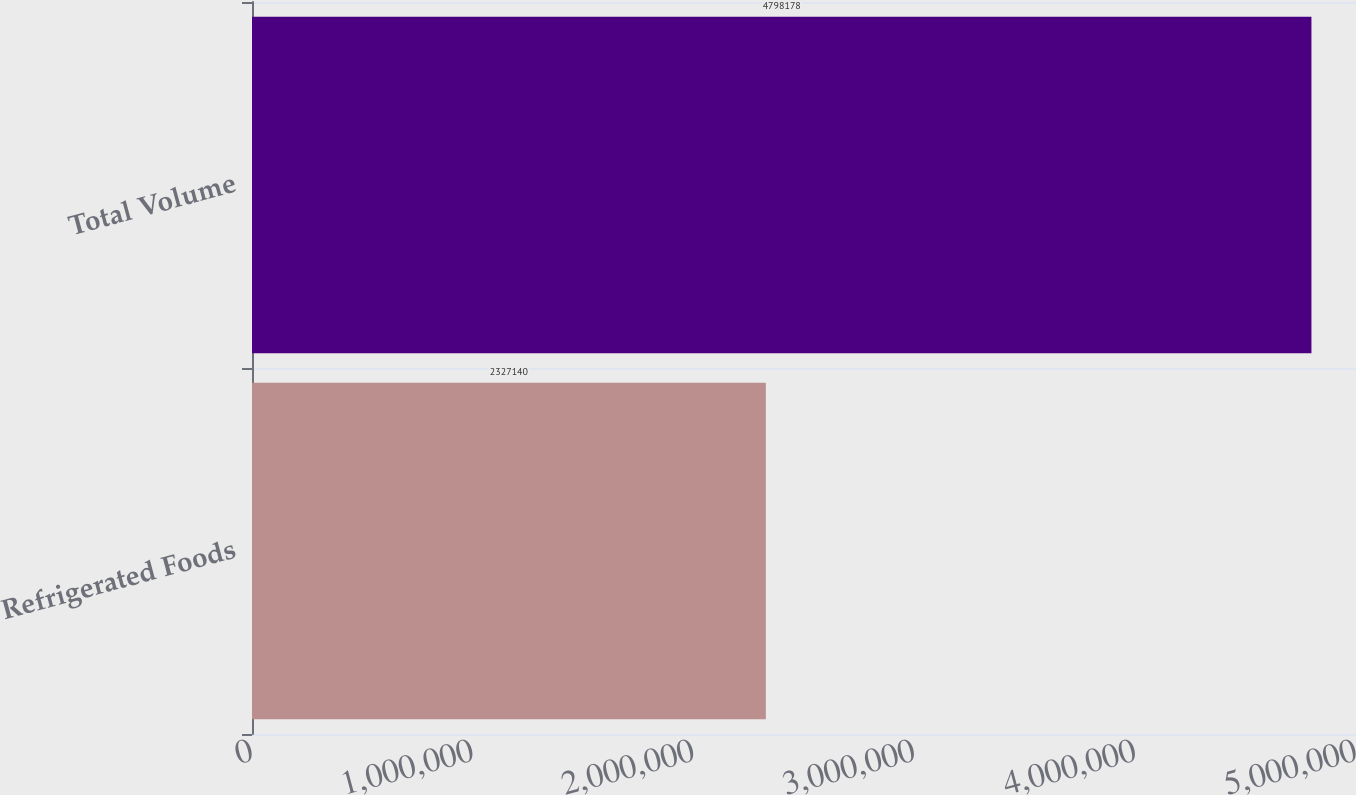Convert chart to OTSL. <chart><loc_0><loc_0><loc_500><loc_500><bar_chart><fcel>Refrigerated Foods<fcel>Total Volume<nl><fcel>2.32714e+06<fcel>4.79818e+06<nl></chart> 